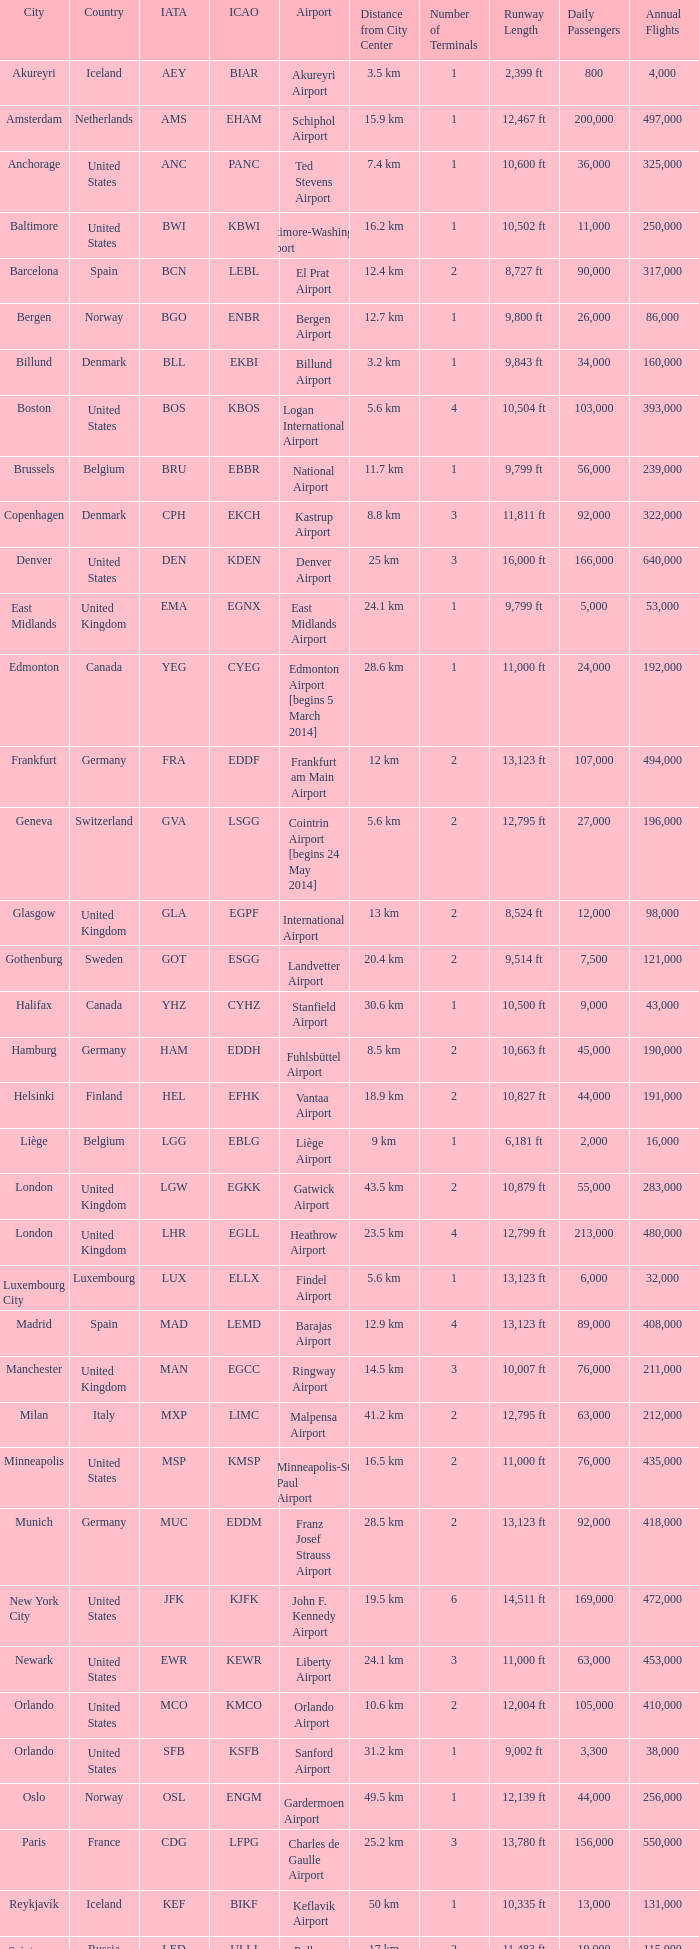Identify the airport associated with the icao designation ksea. Seattle–Tacoma Airport. 